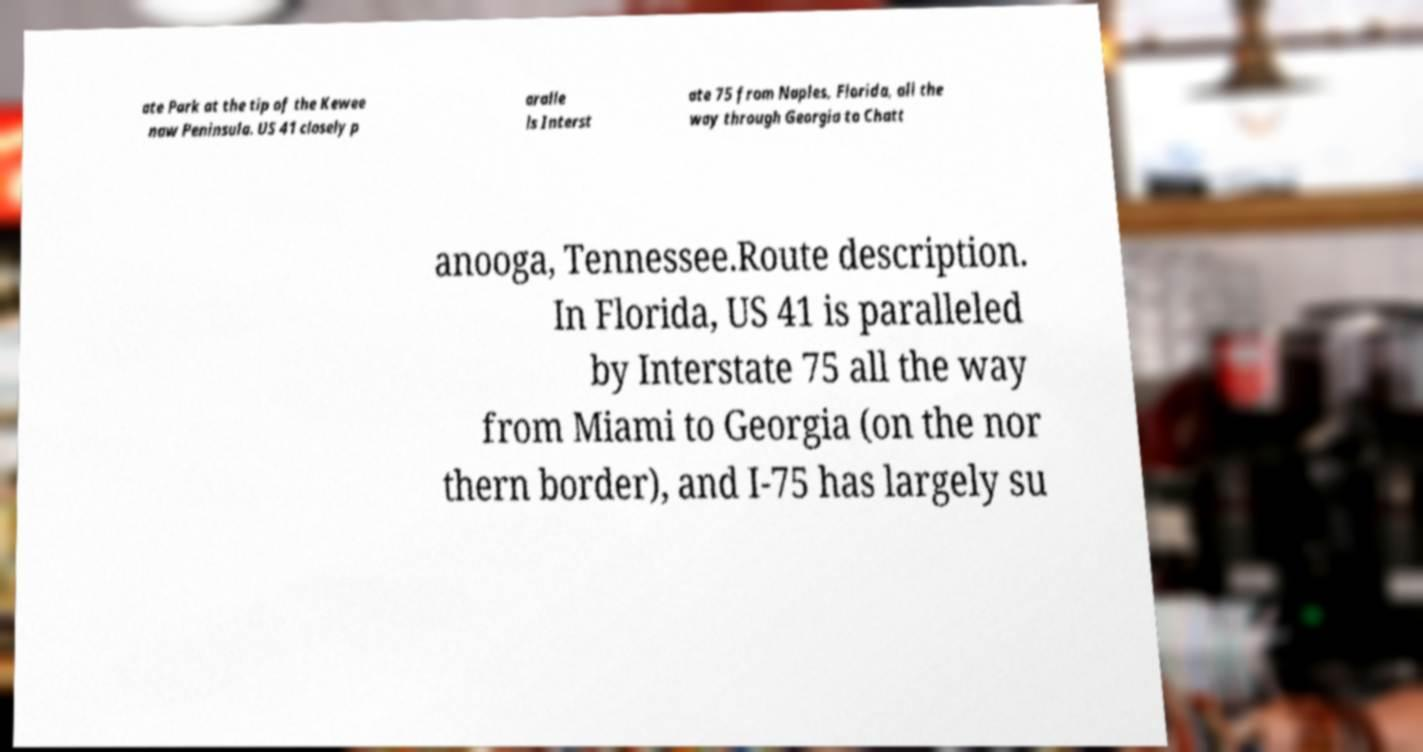Can you read and provide the text displayed in the image?This photo seems to have some interesting text. Can you extract and type it out for me? ate Park at the tip of the Kewee naw Peninsula. US 41 closely p aralle ls Interst ate 75 from Naples, Florida, all the way through Georgia to Chatt anooga, Tennessee.Route description. In Florida, US 41 is paralleled by Interstate 75 all the way from Miami to Georgia (on the nor thern border), and I-75 has largely su 